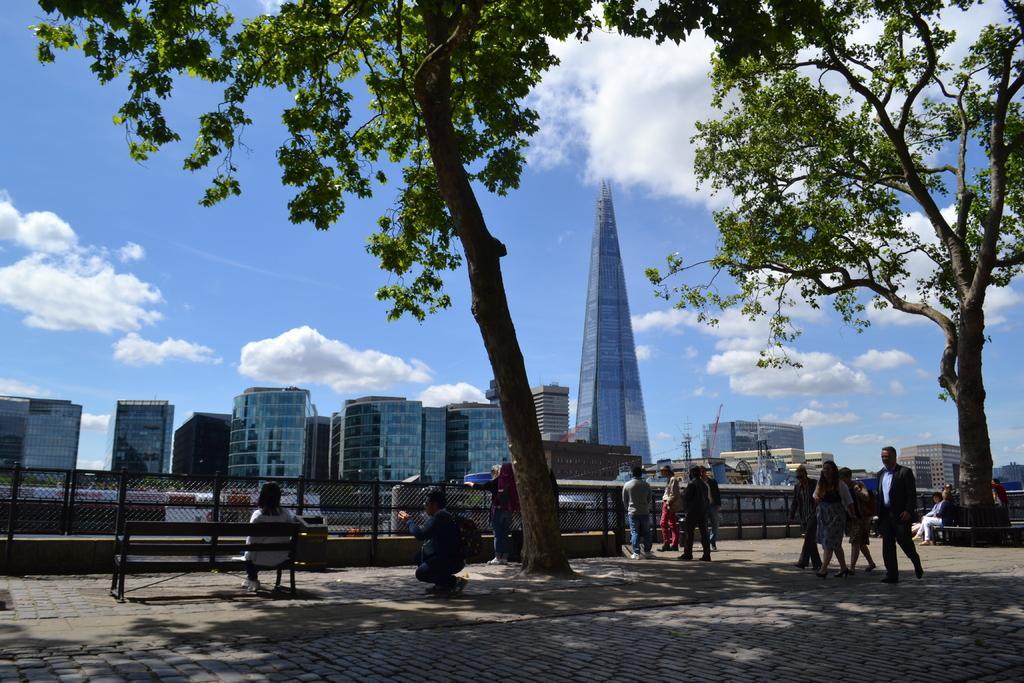Describe this image in one or two sentences. Few people walking,few people standing and this person sitting on a bench and this person sitting like squat position and work bag. We can see trees and fence. In the background we can see buildings and sky with clouds. 